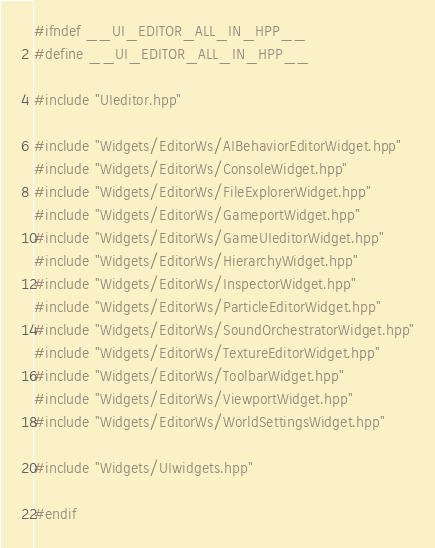<code> <loc_0><loc_0><loc_500><loc_500><_C++_>#ifndef __UI_EDITOR_ALL_IN_HPP__
#define __UI_EDITOR_ALL_IN_HPP__

#include "UIeditor.hpp"

#include "Widgets/EditorWs/AIBehaviorEditorWidget.hpp"
#include "Widgets/EditorWs/ConsoleWidget.hpp"
#include "Widgets/EditorWs/FileExplorerWidget.hpp"
#include "Widgets/EditorWs/GameportWidget.hpp"
#include "Widgets/EditorWs/GameUIeditorWidget.hpp"
#include "Widgets/EditorWs/HierarchyWidget.hpp"
#include "Widgets/EditorWs/InspectorWidget.hpp"
#include "Widgets/EditorWs/ParticleEditorWidget.hpp"
#include "Widgets/EditorWs/SoundOrchestratorWidget.hpp"
#include "Widgets/EditorWs/TextureEditorWidget.hpp"
#include "Widgets/EditorWs/ToolbarWidget.hpp"
#include "Widgets/EditorWs/ViewportWidget.hpp"
#include "Widgets/EditorWs/WorldSettingsWidget.hpp"

#include "Widgets/UIwidgets.hpp"

#endif</code> 